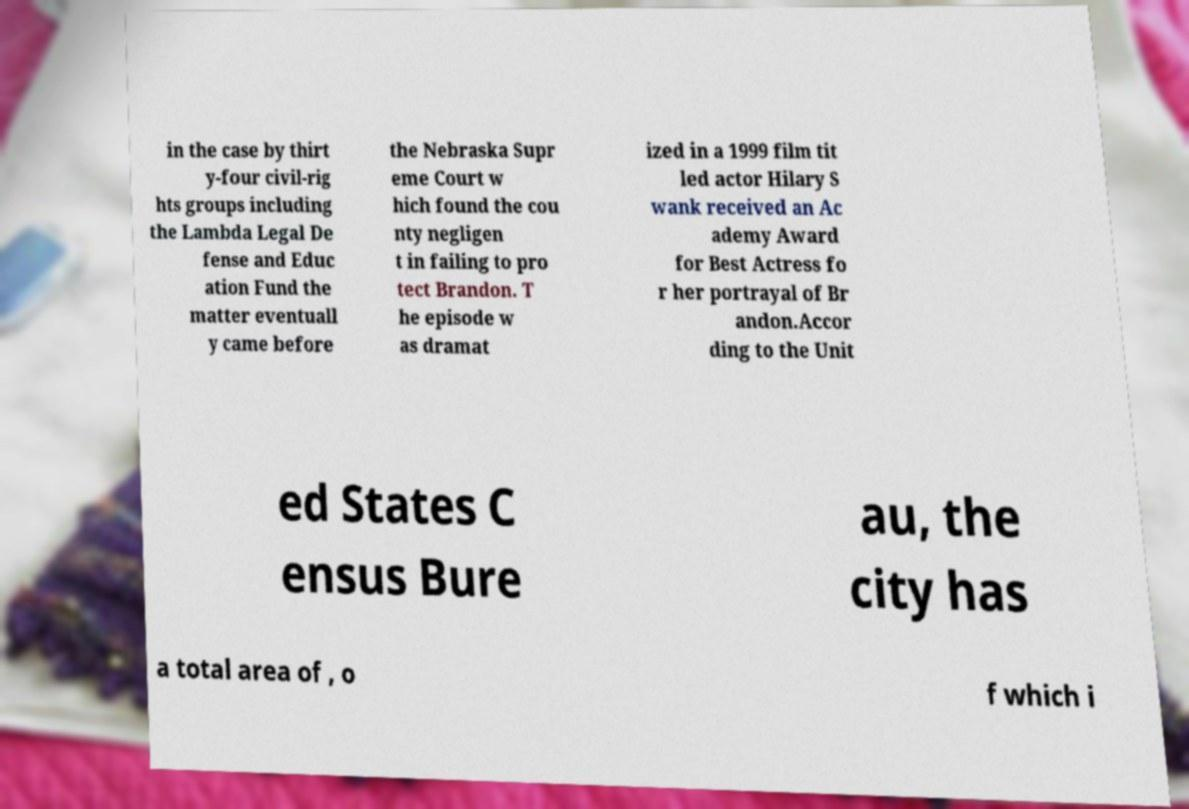What messages or text are displayed in this image? I need them in a readable, typed format. in the case by thirt y-four civil-rig hts groups including the Lambda Legal De fense and Educ ation Fund the matter eventuall y came before the Nebraska Supr eme Court w hich found the cou nty negligen t in failing to pro tect Brandon. T he episode w as dramat ized in a 1999 film tit led actor Hilary S wank received an Ac ademy Award for Best Actress fo r her portrayal of Br andon.Accor ding to the Unit ed States C ensus Bure au, the city has a total area of , o f which i 